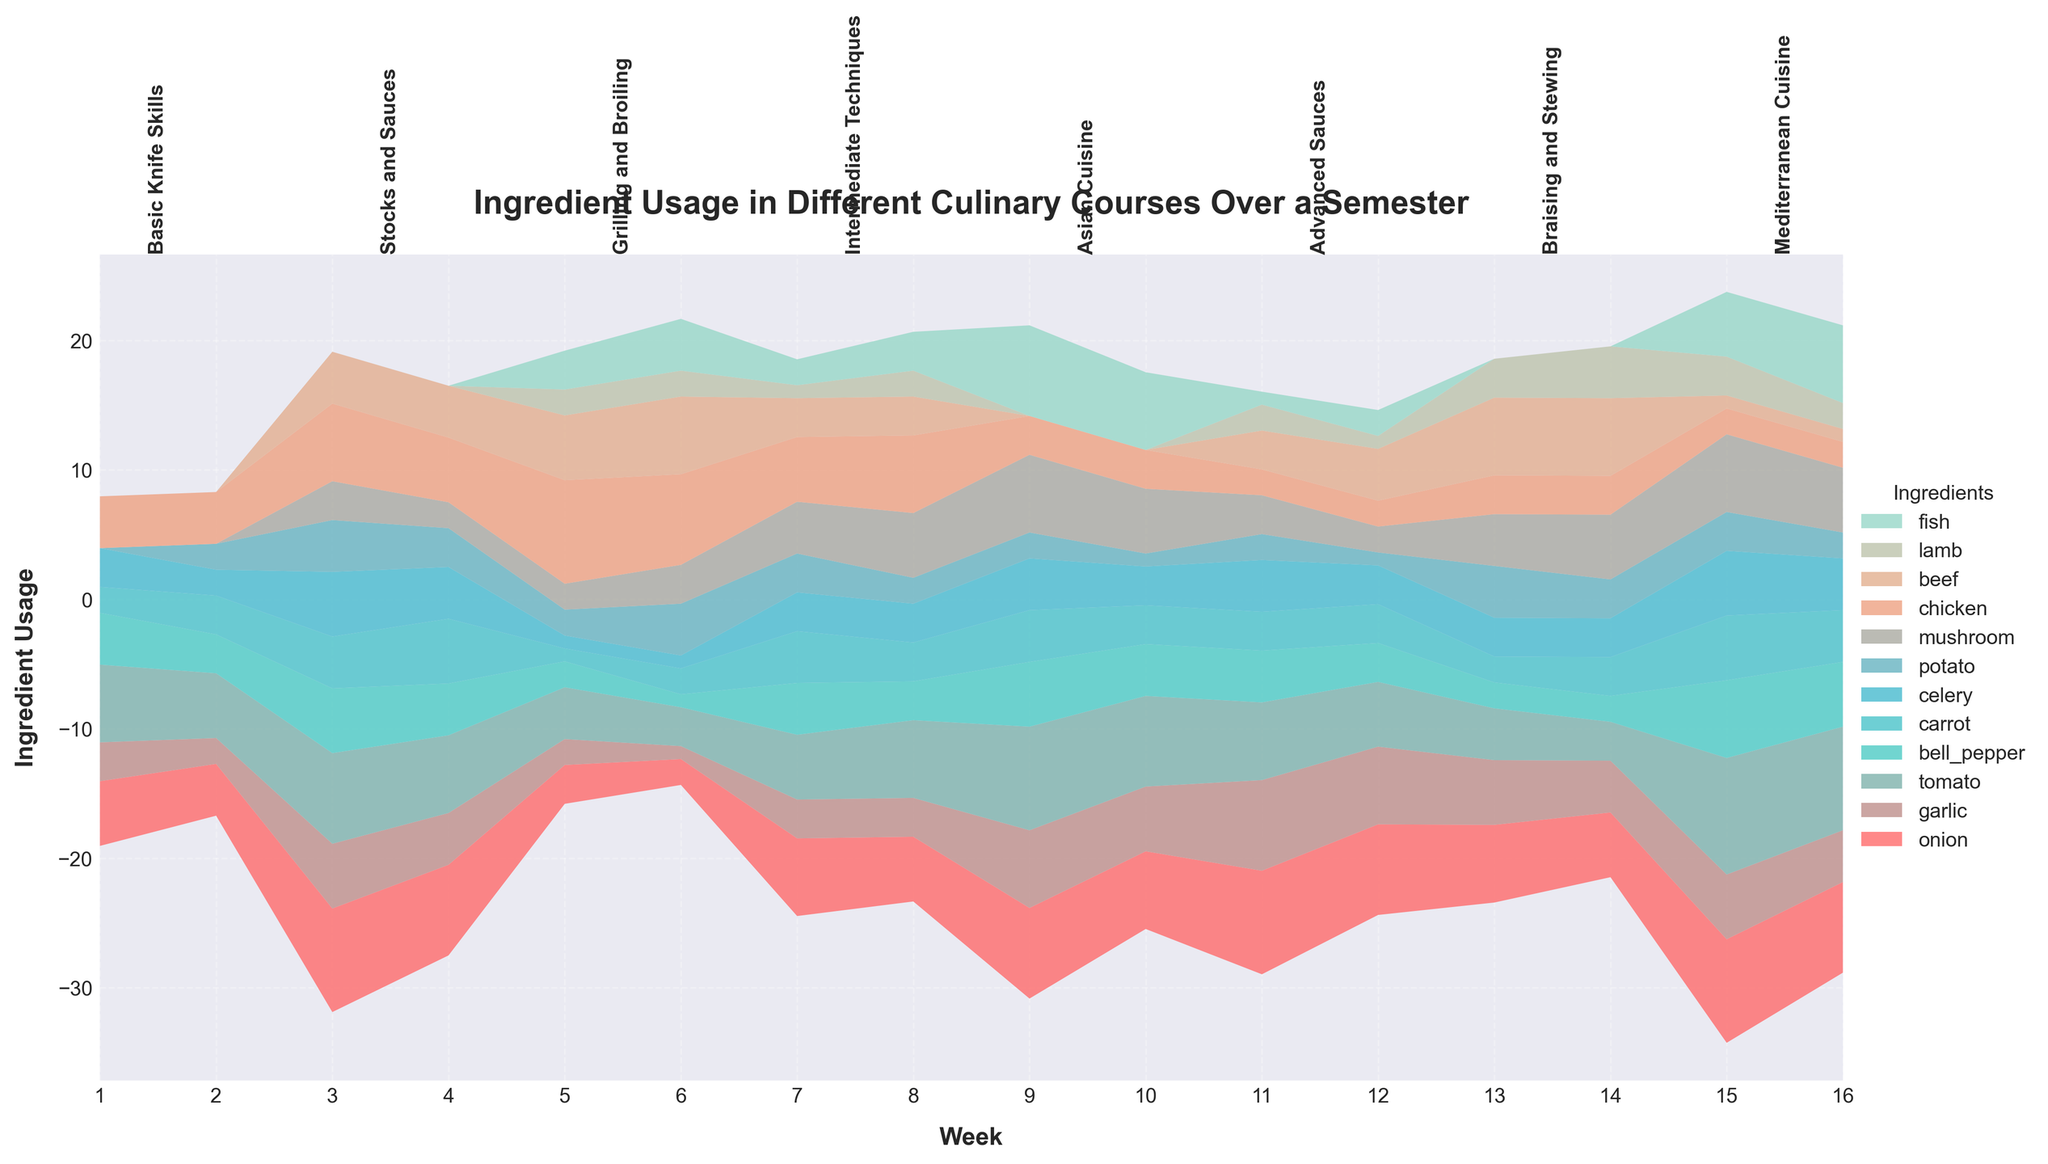What is the title of the figure? The title of a figure is typically found at the top of the plot. Here, it reads "Ingredient Usage in Different Culinary Courses Over a Semester."
Answer: Ingredient Usage in Different Culinary Courses Over a Semester In which week did the "Grilling and Broiling" course begin? To find this, look at the labels for the courses along the x-axis. The "Grilling and Broiling" course is labeled to begin at week 5.
Answer: Week 5 What ingredient has the highest usage in the "Mediterranean Cuisine" course overall? To determine this, look at the ingredient layers from weeks 15 to 16 and compare the heights. "Tomato" has the highest overall usage.
Answer: Tomato Which ingredient has the most usage during the "Stocks and Sauces" course? You need to look at weeks 3 and 4 to see the contributions of each ingredient. "Onion" extends the most during these weeks.
Answer: Onion Compare the usage of chicken and beef in the "Braising and Stewing" course. Which one was used more? Inspect the weeks labeled for "Braising and Stewing" (weeks 13-14). Compare the layers for chicken and beef; beef occupies a larger area.
Answer: Beef What week saw the peak usage of mushrooms? By examining the plot, you can see that mushrooms peak highest in week 9 during the "Asian Cuisine" course.
Answer: Week 9 Which course shows a notable use of lamb? Look at the data over the 16 weeks, and you'll notice lamb is significant in weeks 5-6 during the "Grilling and Broiling" course.
Answer: Grilling and Broiling What's the total usage of carrots across all courses during the semester? Sum the heights of the carrot layer from week 1 to week 16. The values are 2, 3, 4, 5, 1, 2, 4, 3, 4, 3, 3, 3, 2, 2, 5, 4. Adding these, you get 52.
Answer: 52 What ingredient usage increases significantly during the "Asian Cuisine" course compared to previous weeks? Compare weeks before and during the "Asian Cuisine" course (weeks 9-10). "Mushroom" shows a significant increase during these weeks.
Answer: Mushroom 